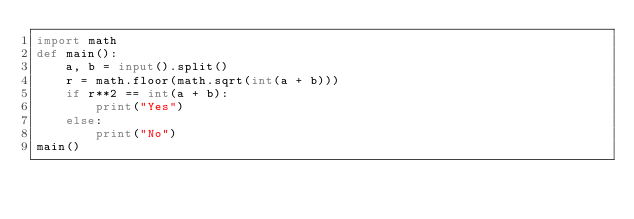Convert code to text. <code><loc_0><loc_0><loc_500><loc_500><_Python_>import math
def main():
    a, b = input().split()
    r = math.floor(math.sqrt(int(a + b)))
    if r**2 == int(a + b):
        print("Yes")
    else:
        print("No")
main()</code> 